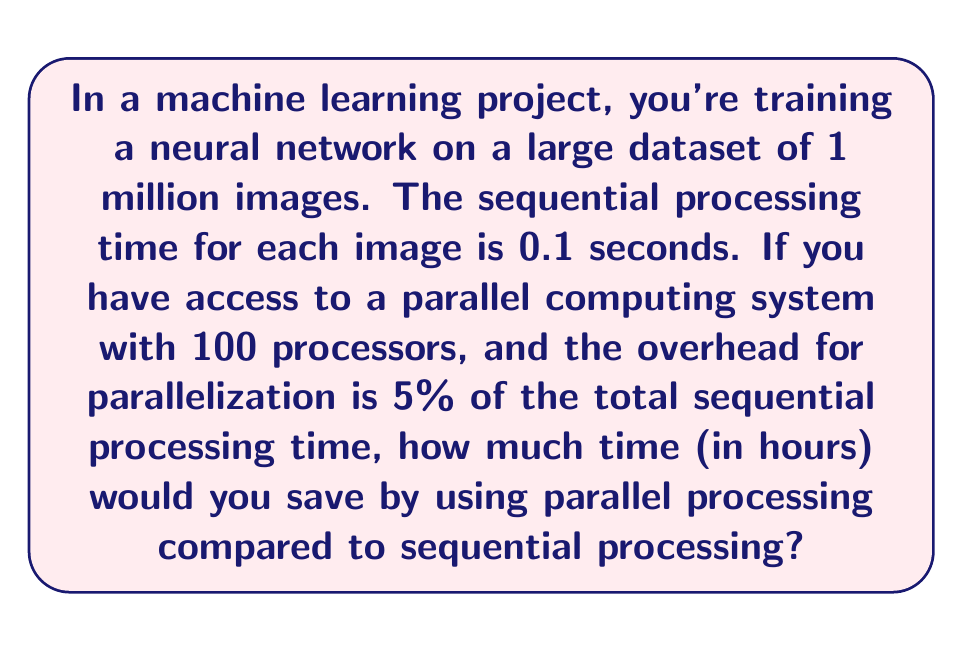Give your solution to this math problem. Let's approach this step-by-step:

1) First, calculate the total sequential processing time:
   $$T_{sequential} = 1,000,000 \text{ images} \times 0.1 \text{ seconds/image} = 100,000 \text{ seconds}$$

2) Convert this to hours:
   $$T_{sequential} = \frac{100,000 \text{ seconds}}{3600 \text{ seconds/hour}} \approx 27.78 \text{ hours}$$

3) For parallel processing, we need to consider the number of processors and the overhead:
   - Number of processors: 100
   - Overhead: 5% of sequential time = $0.05 \times 100,000 = 5,000 \text{ seconds}$

4) Calculate the parallel processing time:
   $$T_{parallel} = \frac{T_{sequential}}{100} + \text{Overhead}$$
   $$T_{parallel} = \frac{100,000}{100} + 5,000 = 1,000 + 5,000 = 6,000 \text{ seconds}$$

5) Convert parallel time to hours:
   $$T_{parallel} = \frac{6,000 \text{ seconds}}{3600 \text{ seconds/hour}} = 1.67 \text{ hours}$$

6) Calculate the time saved:
   $$T_{saved} = T_{sequential} - T_{parallel} = 27.78 - 1.67 = 26.11 \text{ hours}$$

This example demonstrates how parallel computing can significantly reduce the complexity and processing time of machine learning algorithms, especially when dealing with large datasets.
Answer: 26.11 hours 